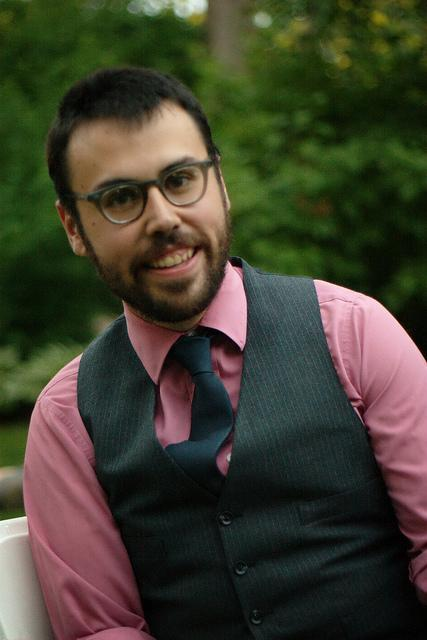Why is he smiling? Please explain your reasoning. for camera. The man is posing. 